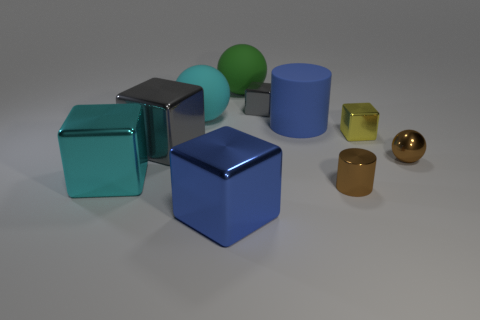Subtract all large cyan rubber spheres. How many spheres are left? 2 Subtract all red balls. How many gray blocks are left? 2 Subtract all gray cubes. How many cubes are left? 3 Subtract 1 cubes. How many cubes are left? 4 Subtract all cylinders. How many objects are left? 8 Subtract all green cubes. Subtract all gray spheres. How many cubes are left? 5 Subtract all yellow rubber objects. Subtract all big cyan blocks. How many objects are left? 9 Add 4 large cubes. How many large cubes are left? 7 Add 5 brown spheres. How many brown spheres exist? 6 Subtract 1 brown spheres. How many objects are left? 9 